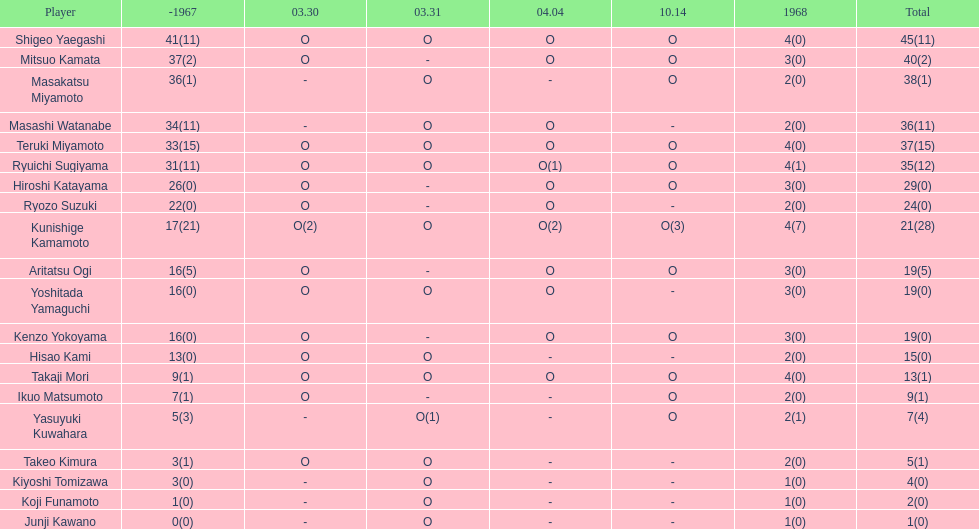Who were the participants in the 1968 japanese football? Shigeo Yaegashi, Mitsuo Kamata, Masakatsu Miyamoto, Masashi Watanabe, Teruki Miyamoto, Ryuichi Sugiyama, Hiroshi Katayama, Ryozo Suzuki, Kunishige Kamamoto, Aritatsu Ogi, Yoshitada Yamaguchi, Kenzo Yokoyama, Hisao Kami, Takaji Mori, Ikuo Matsumoto, Yasuyuki Kuwahara, Takeo Kimura, Kiyoshi Tomizawa, Koji Funamoto, Junji Kawano. What was takaji mori's total score? 13(1). What was junju kawano's total score? 1(0). Who had a higher score? Takaji Mori. 